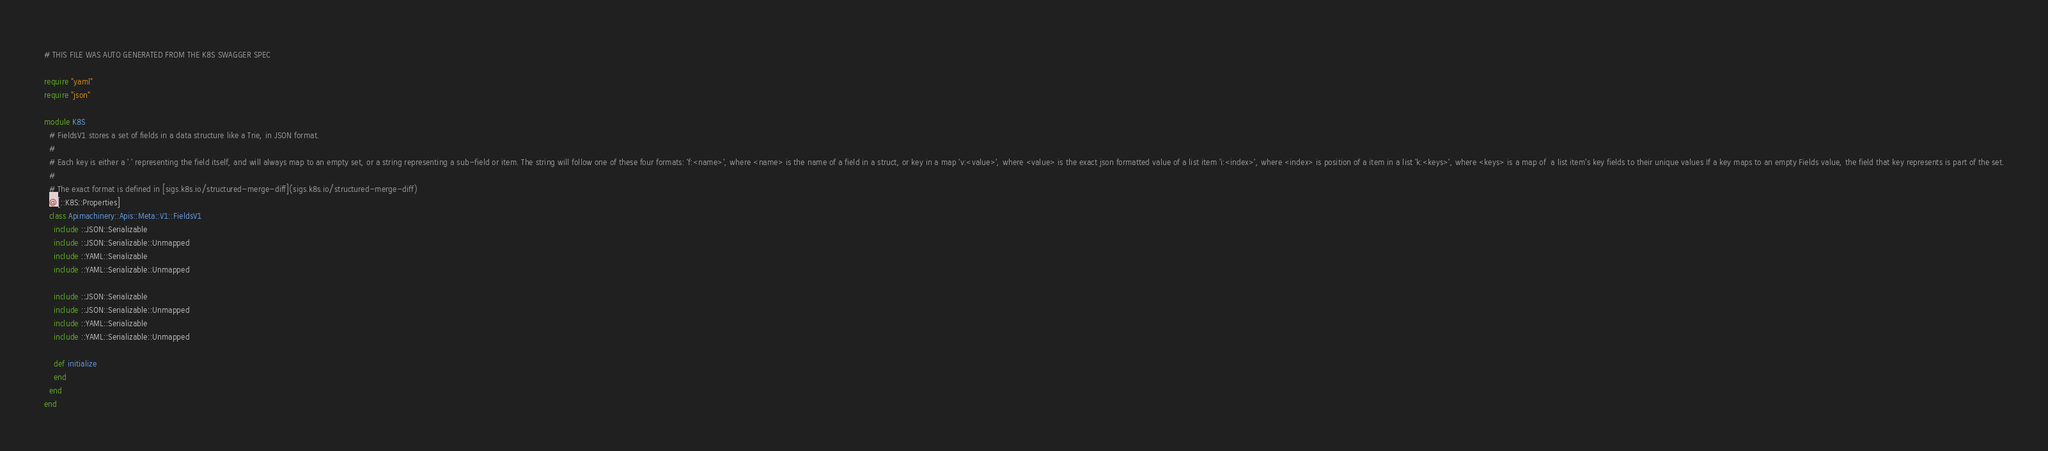<code> <loc_0><loc_0><loc_500><loc_500><_Crystal_># THIS FILE WAS AUTO GENERATED FROM THE K8S SWAGGER SPEC

require "yaml"
require "json"

module K8S
  # FieldsV1 stores a set of fields in a data structure like a Trie, in JSON format.
  #
  # Each key is either a '.' representing the field itself, and will always map to an empty set, or a string representing a sub-field or item. The string will follow one of these four formats: 'f:<name>', where <name> is the name of a field in a struct, or key in a map 'v:<value>', where <value> is the exact json formatted value of a list item 'i:<index>', where <index> is position of a item in a list 'k:<keys>', where <keys> is a map of  a list item's key fields to their unique values If a key maps to an empty Fields value, the field that key represents is part of the set.
  #
  # The exact format is defined in [sigs.k8s.io/structured-merge-diff](sigs.k8s.io/structured-merge-diff)
  @[::K8S::Properties]
  class Apimachinery::Apis::Meta::V1::FieldsV1
    include ::JSON::Serializable
    include ::JSON::Serializable::Unmapped
    include ::YAML::Serializable
    include ::YAML::Serializable::Unmapped

    include ::JSON::Serializable
    include ::JSON::Serializable::Unmapped
    include ::YAML::Serializable
    include ::YAML::Serializable::Unmapped

    def initialize
    end
  end
end
</code> 